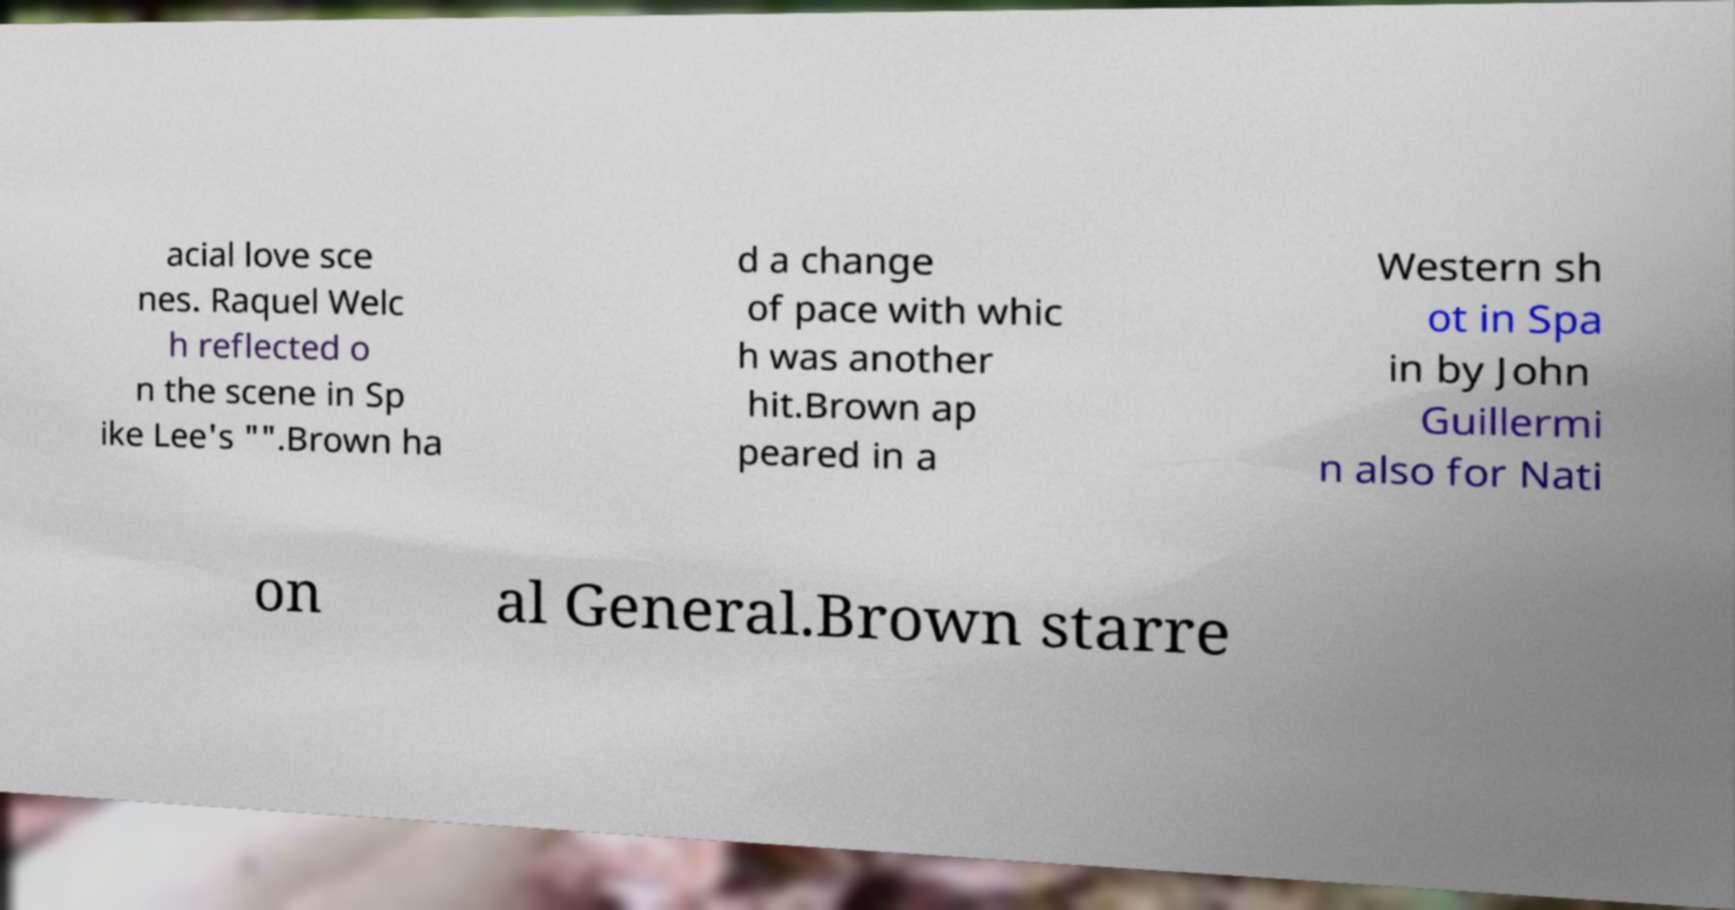Can you read and provide the text displayed in the image?This photo seems to have some interesting text. Can you extract and type it out for me? acial love sce nes. Raquel Welc h reflected o n the scene in Sp ike Lee's "".Brown ha d a change of pace with whic h was another hit.Brown ap peared in a Western sh ot in Spa in by John Guillermi n also for Nati on al General.Brown starre 